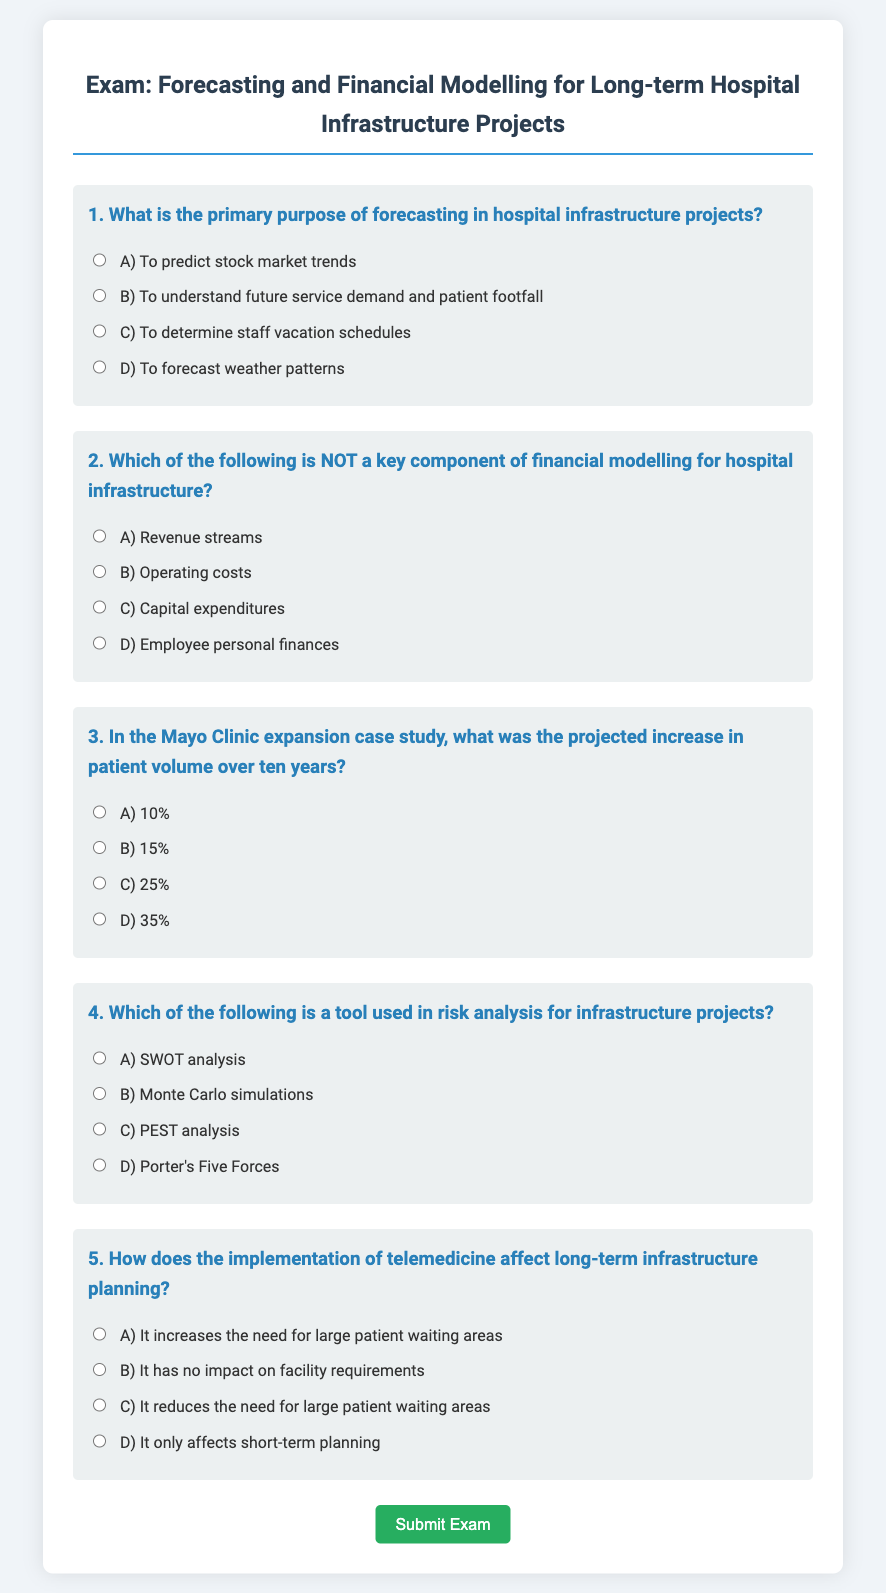What is the primary purpose of forecasting in hospital infrastructure projects? The document states that the primary purpose of forecasting in hospital infrastructure projects is to understand future service demand and patient footfall.
Answer: To understand future service demand and patient footfall Which option is NOT a key component of financial modelling for hospital infrastructure? The document lists revenue streams, operating costs, and capital expenditures as key components, while employee personal finances are not included.
Answer: Employee personal finances What was the projected increase in patient volume over ten years in the Mayo Clinic expansion case study? According to the document, the projected increase in patient volume was 25% over ten years.
Answer: 25% What is a tool used in risk analysis for infrastructure projects? The document mentions that Monte Carlo simulations are a tool used in risk analysis for infrastructure projects.
Answer: Monte Carlo simulations How does telemedicine affect long-term infrastructure planning? The document indicates that telemedicine reduces the need for large patient waiting areas in long-term infrastructure planning.
Answer: It reduces the need for large patient waiting areas 